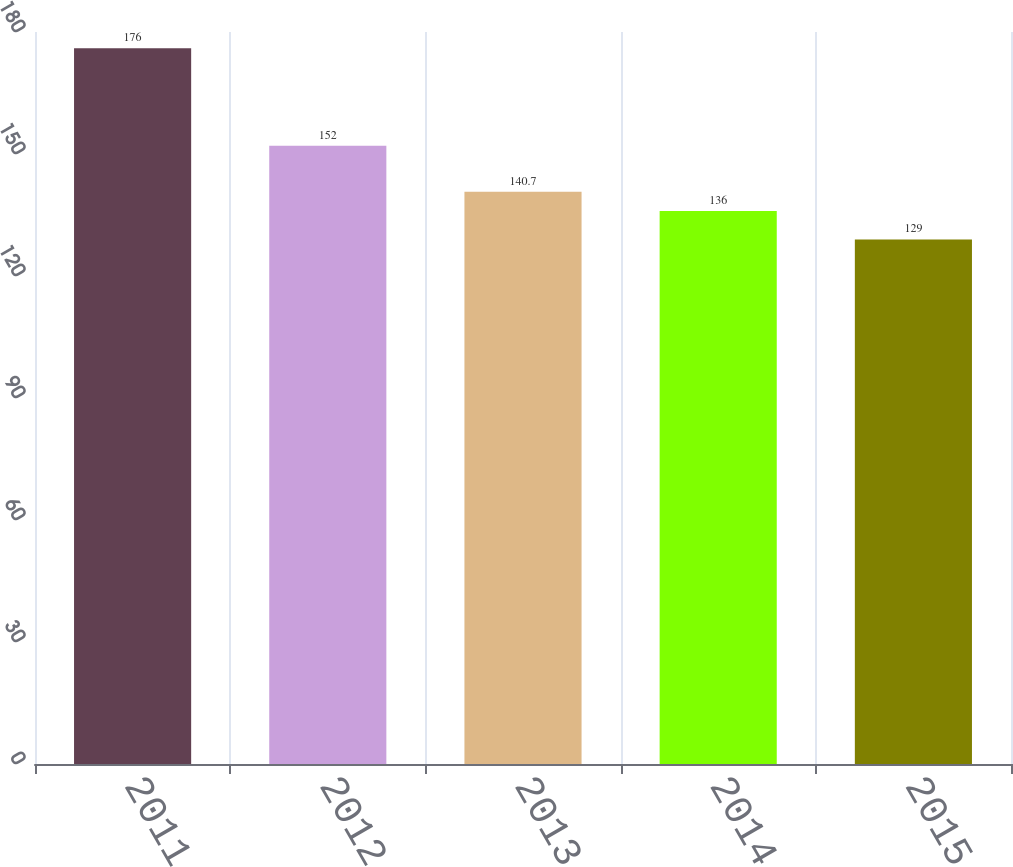Convert chart to OTSL. <chart><loc_0><loc_0><loc_500><loc_500><bar_chart><fcel>2011<fcel>2012<fcel>2013<fcel>2014<fcel>2015<nl><fcel>176<fcel>152<fcel>140.7<fcel>136<fcel>129<nl></chart> 